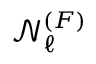Convert formula to latex. <formula><loc_0><loc_0><loc_500><loc_500>\mathcal { N } _ { \ell } ^ { ( F ) }</formula> 